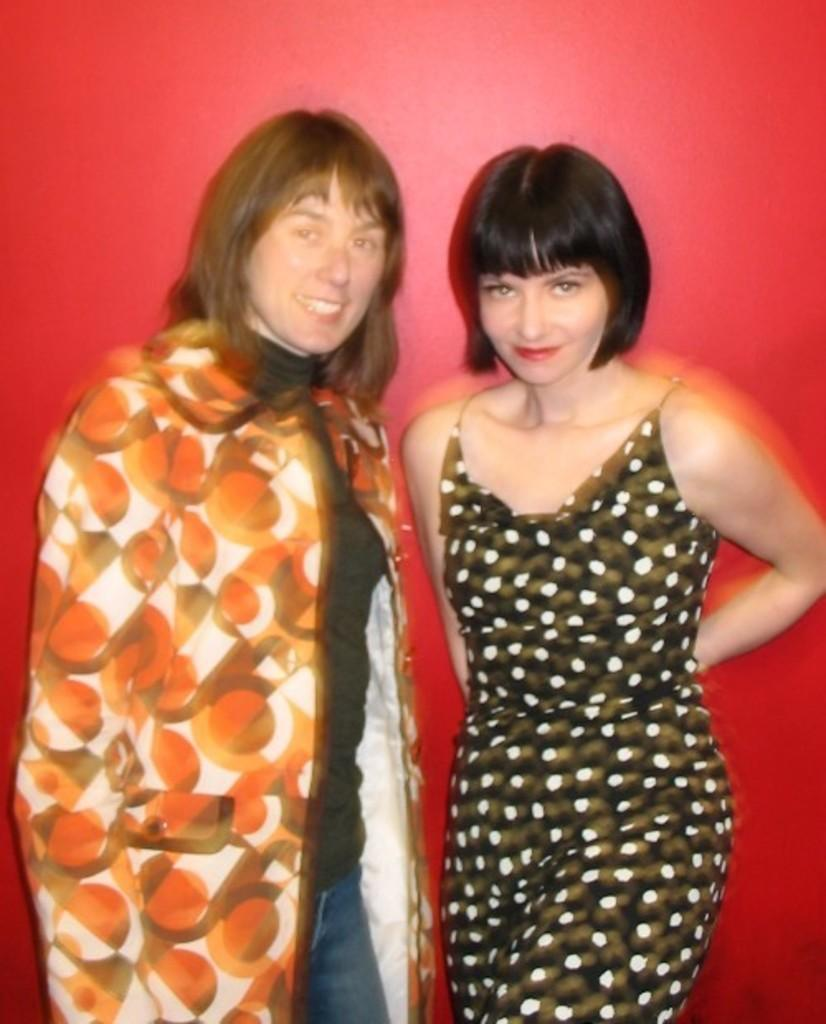What is the main subject of the image? There is a beautiful woman in the image. What is the woman doing in the image? The woman is standing. What is the woman wearing in the image? The woman is wearing a top. Who else is present in the image? There is a person on the left side of the image. What is the expression of the person on the left side? The person on the left side is smiling. What is the person on the left side wearing? The person on the left side is wearing an orange coat. What type of cakes are being served at the country event in the image? There is no country event or cakes present in the image. What is the person on the left side hoping for in the image? There is no indication of hope or any specific desires in the image. 